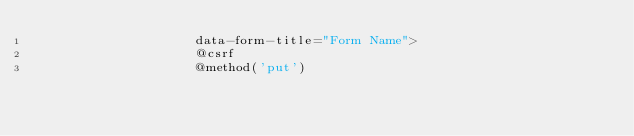<code> <loc_0><loc_0><loc_500><loc_500><_PHP_>                    data-form-title="Form Name">
                    @csrf
                    @method('put')</code> 